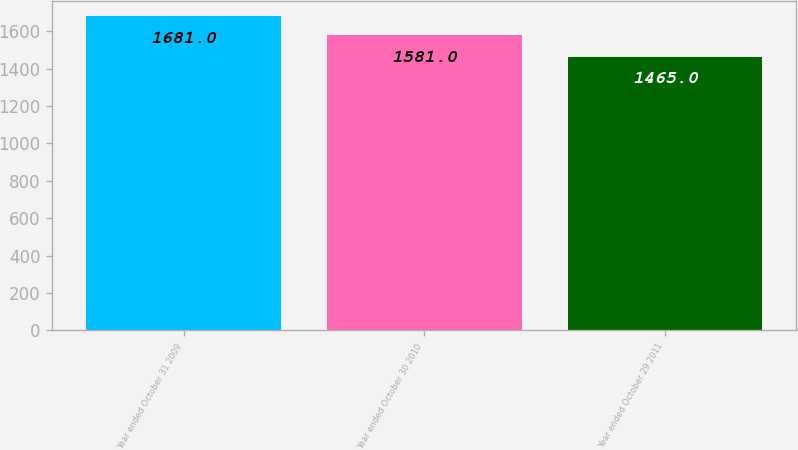Convert chart. <chart><loc_0><loc_0><loc_500><loc_500><bar_chart><fcel>Year ended October 31 2009<fcel>Year ended October 30 2010<fcel>Year ended October 29 2011<nl><fcel>1681<fcel>1581<fcel>1465<nl></chart> 